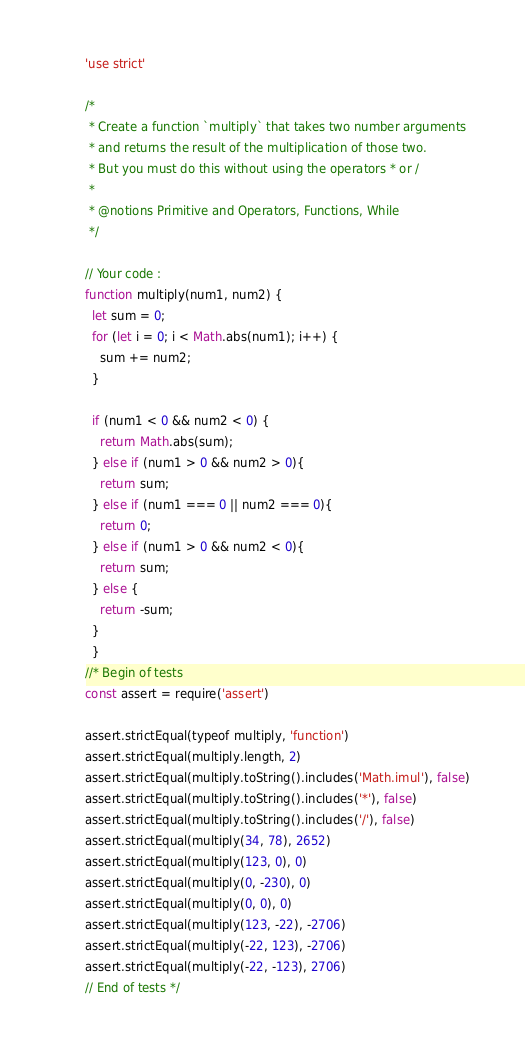<code> <loc_0><loc_0><loc_500><loc_500><_JavaScript_>'use strict'

/*
 * Create a function `multiply` that takes two number arguments
 * and returns the result of the multiplication of those two.
 * But you must do this without using the operators * or /
 *
 * @notions Primitive and Operators, Functions, While
 */

// Your code :
function multiply(num1, num2) {
  let sum = 0;
  for (let i = 0; i < Math.abs(num1); i++) {
    sum += num2;
  }

  if (num1 < 0 && num2 < 0) {
    return Math.abs(sum);
  } else if (num1 > 0 && num2 > 0){
    return sum;
  } else if (num1 === 0 || num2 === 0){
    return 0;
  } else if (num1 > 0 && num2 < 0){
    return sum;
  } else {
    return -sum;
  }
  }
//* Begin of tests
const assert = require('assert')

assert.strictEqual(typeof multiply, 'function')
assert.strictEqual(multiply.length, 2)
assert.strictEqual(multiply.toString().includes('Math.imul'), false)
assert.strictEqual(multiply.toString().includes('*'), false)
assert.strictEqual(multiply.toString().includes('/'), false)
assert.strictEqual(multiply(34, 78), 2652)
assert.strictEqual(multiply(123, 0), 0)
assert.strictEqual(multiply(0, -230), 0)
assert.strictEqual(multiply(0, 0), 0)
assert.strictEqual(multiply(123, -22), -2706)
assert.strictEqual(multiply(-22, 123), -2706)
assert.strictEqual(multiply(-22, -123), 2706)
// End of tests */
</code> 